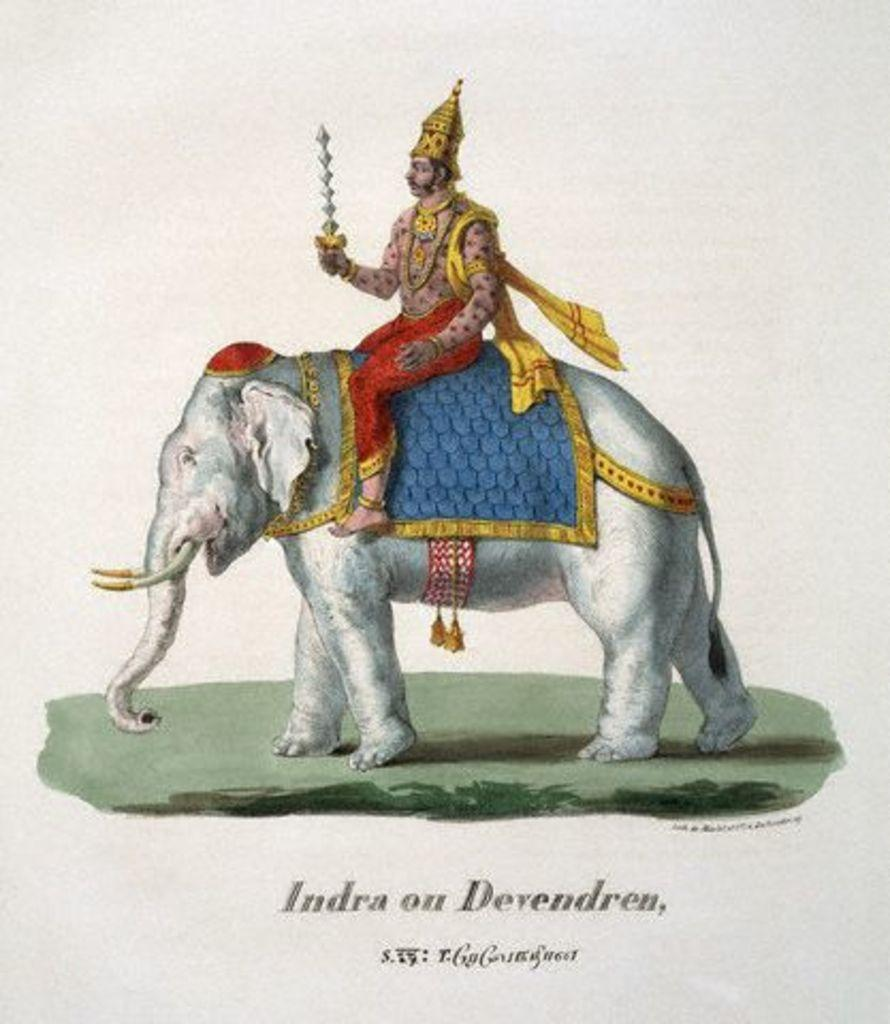What type of artwork is depicted in the image? The image is a painting. Who or what is the main subject of the painting? There is a god in the painting. What is the god doing in the painting? The god is sitting on an elephant. What color is the elephant in the painting? The elephant is white in color. What type of wax is used to create the painting? The painting is not made of wax; it is a traditional painting, likely created with paint on a canvas or other surface. 